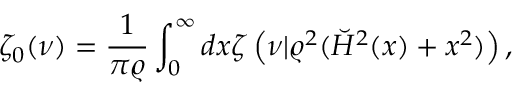<formula> <loc_0><loc_0><loc_500><loc_500>\zeta _ { 0 } ( \nu ) = { \frac { 1 } { \pi \varrho } } \int _ { 0 } ^ { \infty } d x \zeta \left ( \nu | \varrho ^ { 2 } ( \breve { H } ^ { 2 } ( x ) + x ^ { 2 } ) \right ) ,</formula> 